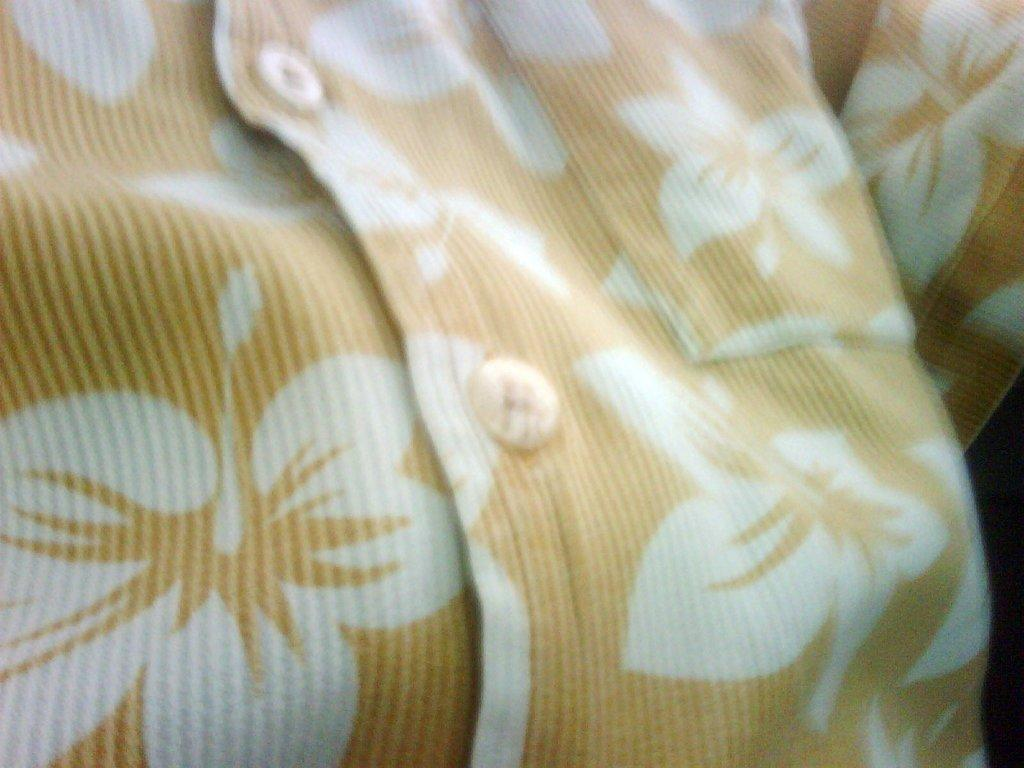What type of clothing is visible in the image? There is a printed shirt in the image. How many quince are being coached in the image? There are no quince or coaches present in the image; it only features a printed shirt. 